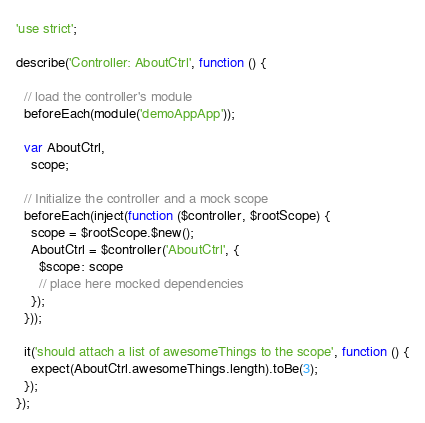Convert code to text. <code><loc_0><loc_0><loc_500><loc_500><_JavaScript_>'use strict';

describe('Controller: AboutCtrl', function () {

  // load the controller's module
  beforeEach(module('demoAppApp'));

  var AboutCtrl,
    scope;

  // Initialize the controller and a mock scope
  beforeEach(inject(function ($controller, $rootScope) {
    scope = $rootScope.$new();
    AboutCtrl = $controller('AboutCtrl', {
      $scope: scope
      // place here mocked dependencies
    });
  }));

  it('should attach a list of awesomeThings to the scope', function () {
    expect(AboutCtrl.awesomeThings.length).toBe(3);
  });
});
</code> 